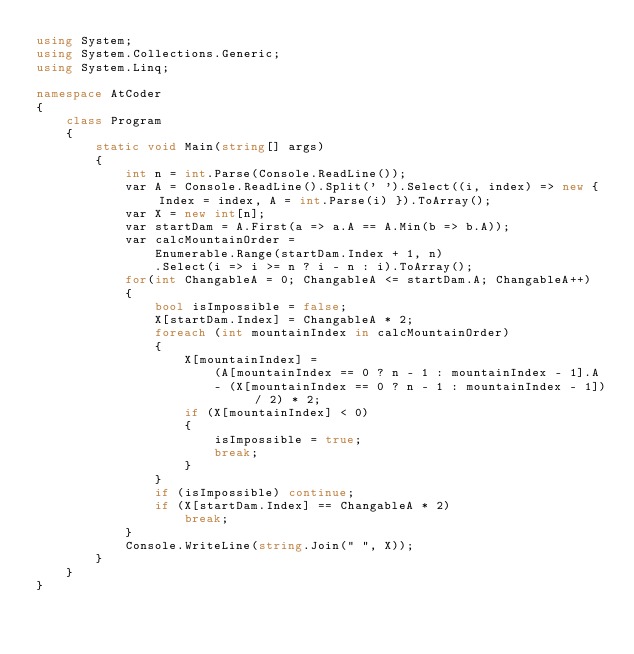<code> <loc_0><loc_0><loc_500><loc_500><_C#_>using System;
using System.Collections.Generic;
using System.Linq;

namespace AtCoder
{
    class Program
    {
        static void Main(string[] args)
        {
            int n = int.Parse(Console.ReadLine());
            var A = Console.ReadLine().Split(' ').Select((i, index) => new { Index = index, A = int.Parse(i) }).ToArray();
            var X = new int[n];
            var startDam = A.First(a => a.A == A.Min(b => b.A));
            var calcMountainOrder =
                Enumerable.Range(startDam.Index + 1, n)
                .Select(i => i >= n ? i - n : i).ToArray();
            for(int ChangableA = 0; ChangableA <= startDam.A; ChangableA++)
            {
                bool isImpossible = false;
                X[startDam.Index] = ChangableA * 2;
                foreach (int mountainIndex in calcMountainOrder)
                {
                    X[mountainIndex] =
                        (A[mountainIndex == 0 ? n - 1 : mountainIndex - 1].A
                        - (X[mountainIndex == 0 ? n - 1 : mountainIndex - 1]) / 2) * 2;
                    if (X[mountainIndex] < 0)
                    {
                        isImpossible = true;
                        break;
                    }
                }
                if (isImpossible) continue;
                if (X[startDam.Index] == ChangableA * 2)
                    break;
            }
            Console.WriteLine(string.Join(" ", X));
        }
    }
}
</code> 